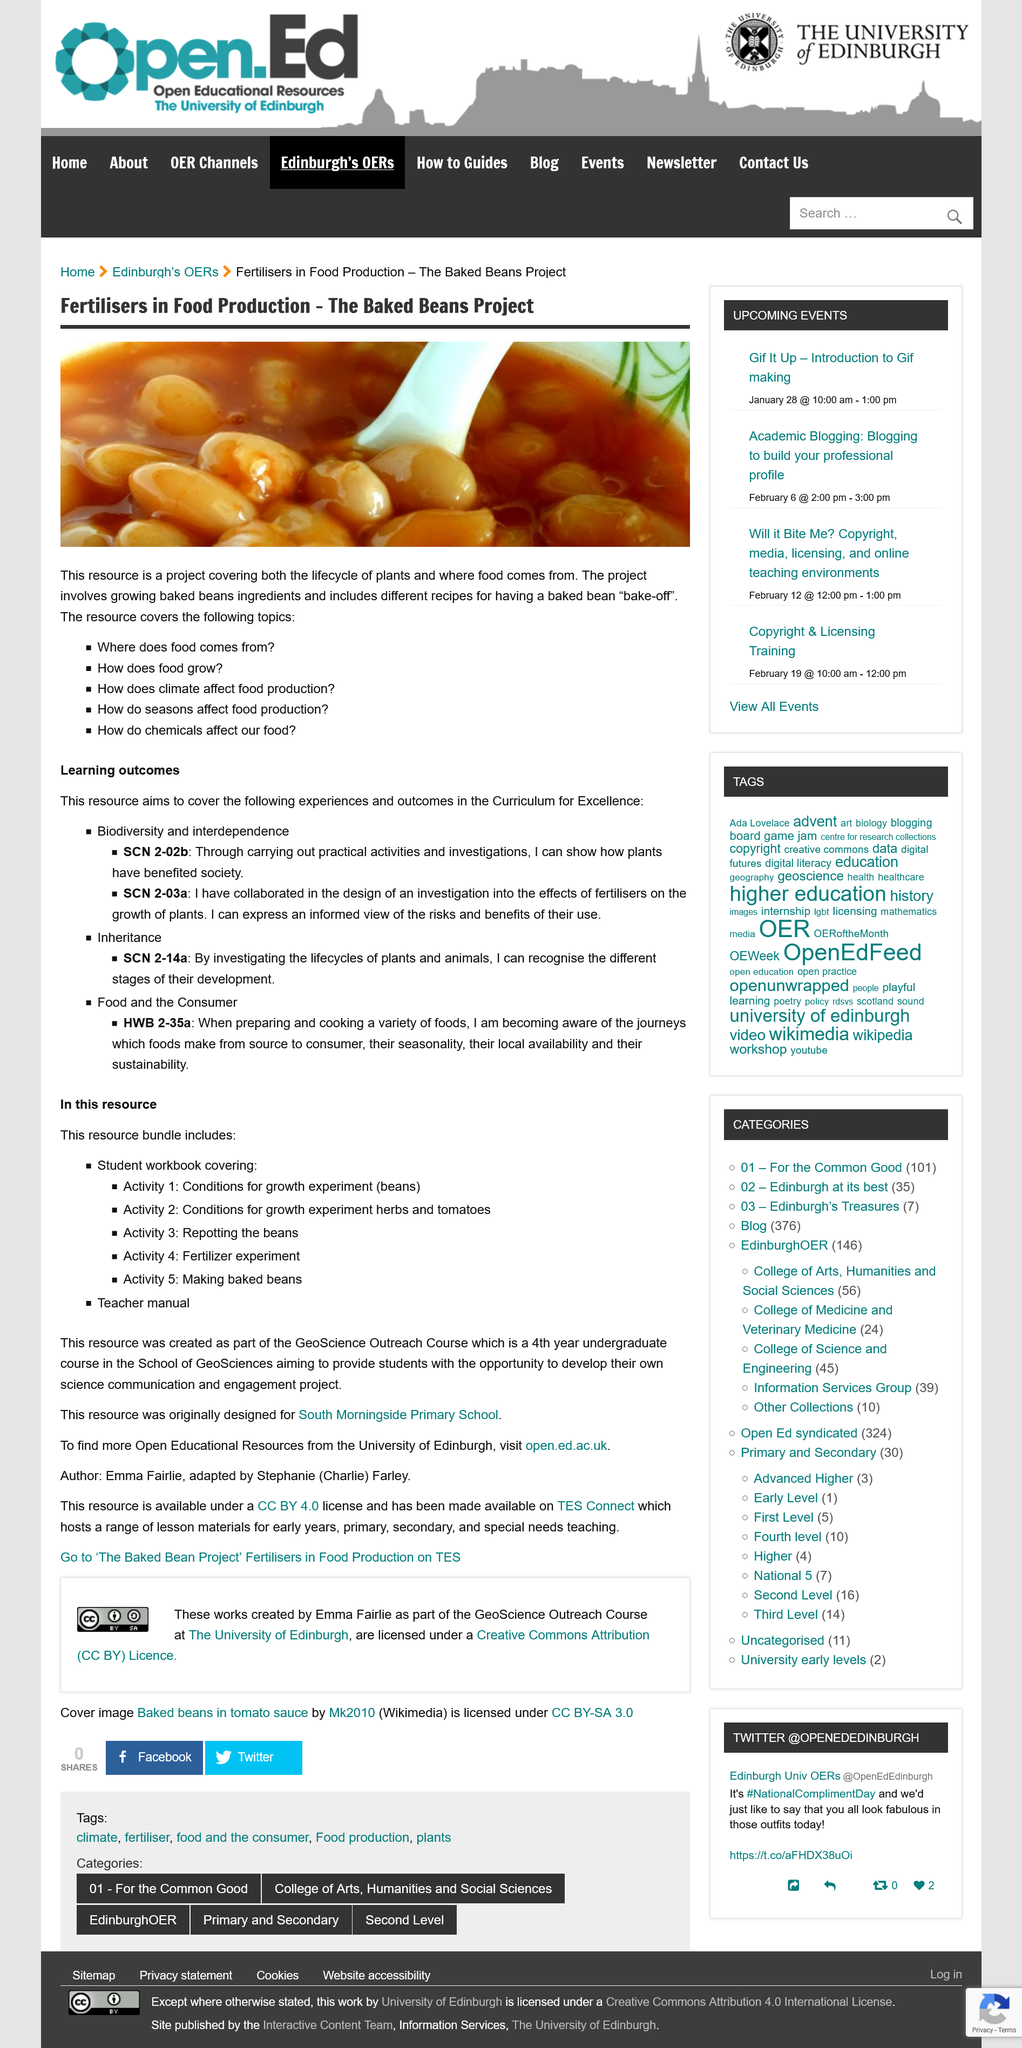Draw attention to some important aspects in this diagram. The Baked Beans Project is a comprehensive resource that provides information on the lifecycle of plants and the origin of food. The project entails having a baked bean "bake-off" with recipes included. The baked beans project aims to achieve three learning outcomes: biodiversity and interdependence, inheritance, and food and consumer sciences. 